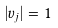<formula> <loc_0><loc_0><loc_500><loc_500>| v _ { j } | = 1</formula> 